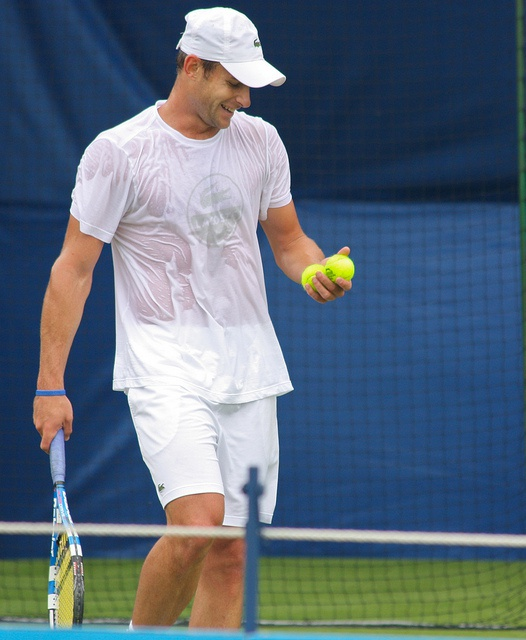Describe the objects in this image and their specific colors. I can see people in darkblue, lavender, salmon, and darkgray tones, tennis racket in darkblue, darkgray, gray, lightgray, and khaki tones, sports ball in darkblue, yellow, and khaki tones, and sports ball in darkblue, khaki, and yellow tones in this image. 